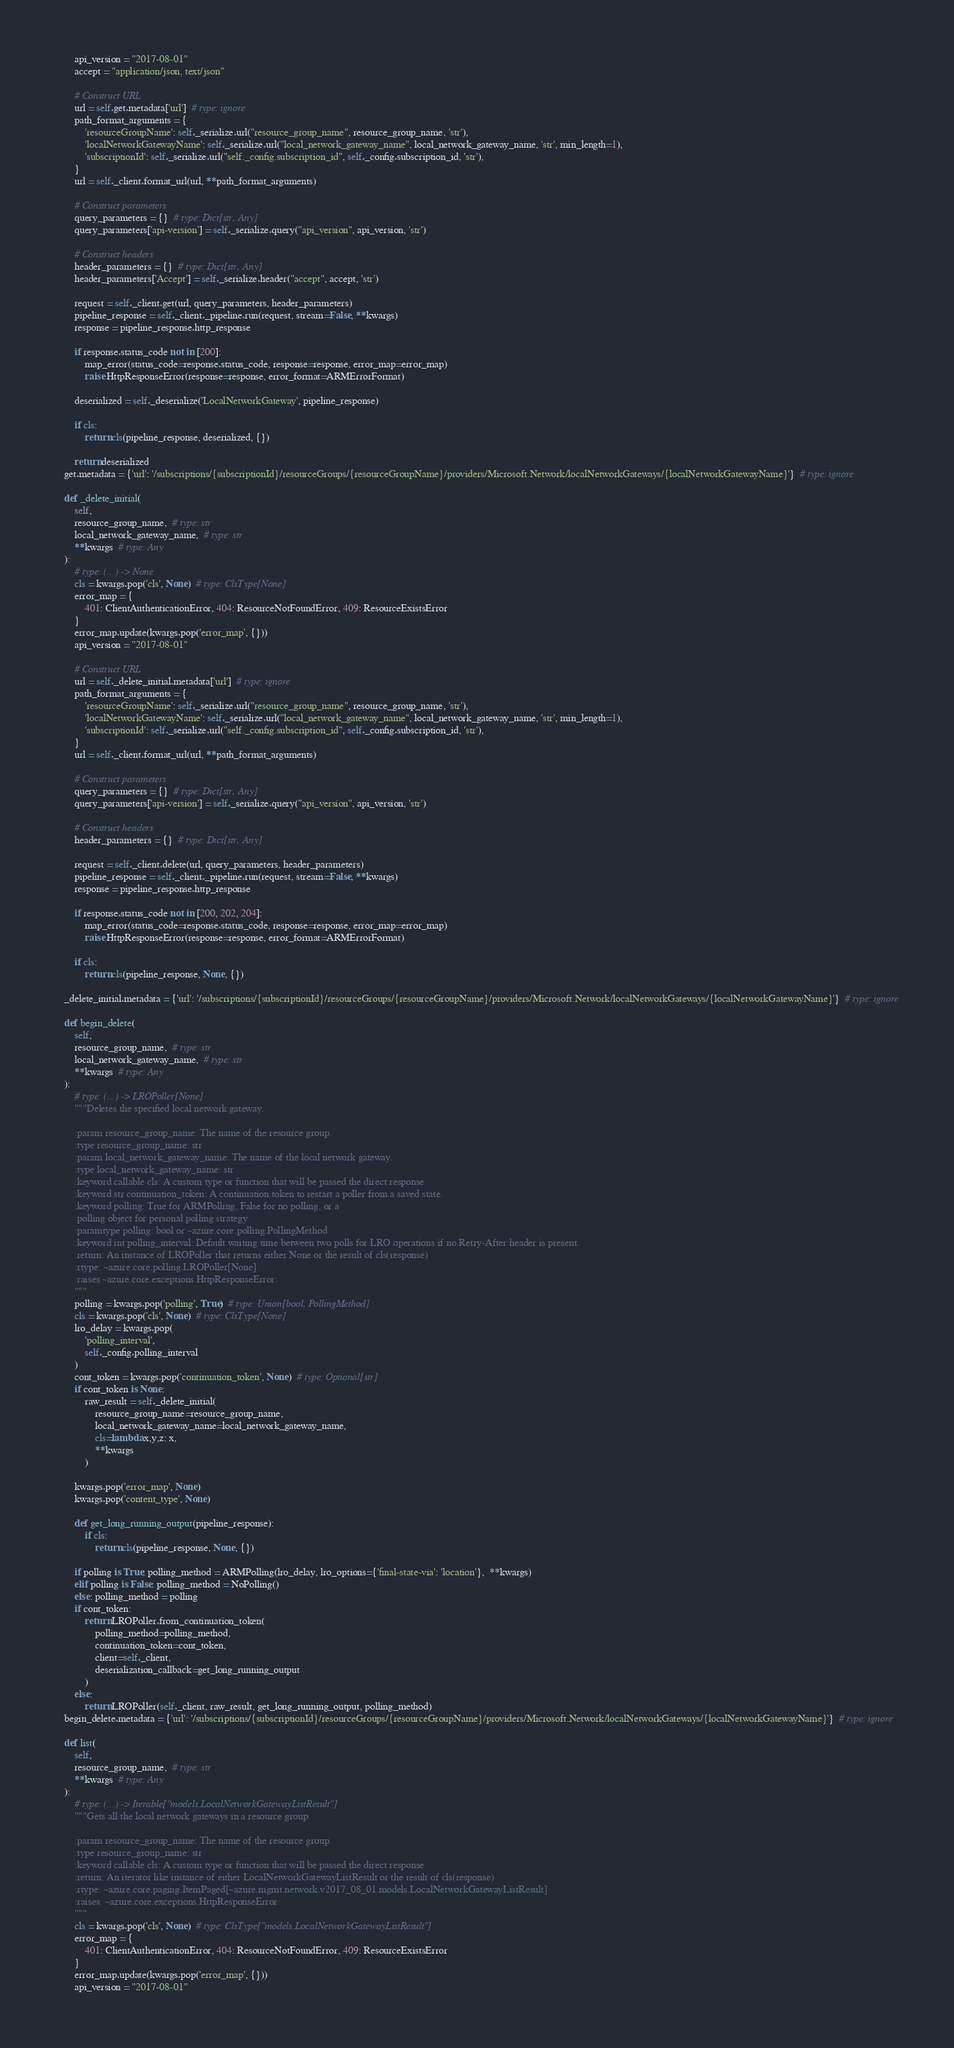<code> <loc_0><loc_0><loc_500><loc_500><_Python_>        api_version = "2017-08-01"
        accept = "application/json, text/json"

        # Construct URL
        url = self.get.metadata['url']  # type: ignore
        path_format_arguments = {
            'resourceGroupName': self._serialize.url("resource_group_name", resource_group_name, 'str'),
            'localNetworkGatewayName': self._serialize.url("local_network_gateway_name", local_network_gateway_name, 'str', min_length=1),
            'subscriptionId': self._serialize.url("self._config.subscription_id", self._config.subscription_id, 'str'),
        }
        url = self._client.format_url(url, **path_format_arguments)

        # Construct parameters
        query_parameters = {}  # type: Dict[str, Any]
        query_parameters['api-version'] = self._serialize.query("api_version", api_version, 'str')

        # Construct headers
        header_parameters = {}  # type: Dict[str, Any]
        header_parameters['Accept'] = self._serialize.header("accept", accept, 'str')

        request = self._client.get(url, query_parameters, header_parameters)
        pipeline_response = self._client._pipeline.run(request, stream=False, **kwargs)
        response = pipeline_response.http_response

        if response.status_code not in [200]:
            map_error(status_code=response.status_code, response=response, error_map=error_map)
            raise HttpResponseError(response=response, error_format=ARMErrorFormat)

        deserialized = self._deserialize('LocalNetworkGateway', pipeline_response)

        if cls:
            return cls(pipeline_response, deserialized, {})

        return deserialized
    get.metadata = {'url': '/subscriptions/{subscriptionId}/resourceGroups/{resourceGroupName}/providers/Microsoft.Network/localNetworkGateways/{localNetworkGatewayName}'}  # type: ignore

    def _delete_initial(
        self,
        resource_group_name,  # type: str
        local_network_gateway_name,  # type: str
        **kwargs  # type: Any
    ):
        # type: (...) -> None
        cls = kwargs.pop('cls', None)  # type: ClsType[None]
        error_map = {
            401: ClientAuthenticationError, 404: ResourceNotFoundError, 409: ResourceExistsError
        }
        error_map.update(kwargs.pop('error_map', {}))
        api_version = "2017-08-01"

        # Construct URL
        url = self._delete_initial.metadata['url']  # type: ignore
        path_format_arguments = {
            'resourceGroupName': self._serialize.url("resource_group_name", resource_group_name, 'str'),
            'localNetworkGatewayName': self._serialize.url("local_network_gateway_name", local_network_gateway_name, 'str', min_length=1),
            'subscriptionId': self._serialize.url("self._config.subscription_id", self._config.subscription_id, 'str'),
        }
        url = self._client.format_url(url, **path_format_arguments)

        # Construct parameters
        query_parameters = {}  # type: Dict[str, Any]
        query_parameters['api-version'] = self._serialize.query("api_version", api_version, 'str')

        # Construct headers
        header_parameters = {}  # type: Dict[str, Any]

        request = self._client.delete(url, query_parameters, header_parameters)
        pipeline_response = self._client._pipeline.run(request, stream=False, **kwargs)
        response = pipeline_response.http_response

        if response.status_code not in [200, 202, 204]:
            map_error(status_code=response.status_code, response=response, error_map=error_map)
            raise HttpResponseError(response=response, error_format=ARMErrorFormat)

        if cls:
            return cls(pipeline_response, None, {})

    _delete_initial.metadata = {'url': '/subscriptions/{subscriptionId}/resourceGroups/{resourceGroupName}/providers/Microsoft.Network/localNetworkGateways/{localNetworkGatewayName}'}  # type: ignore

    def begin_delete(
        self,
        resource_group_name,  # type: str
        local_network_gateway_name,  # type: str
        **kwargs  # type: Any
    ):
        # type: (...) -> LROPoller[None]
        """Deletes the specified local network gateway.

        :param resource_group_name: The name of the resource group.
        :type resource_group_name: str
        :param local_network_gateway_name: The name of the local network gateway.
        :type local_network_gateway_name: str
        :keyword callable cls: A custom type or function that will be passed the direct response
        :keyword str continuation_token: A continuation token to restart a poller from a saved state.
        :keyword polling: True for ARMPolling, False for no polling, or a
         polling object for personal polling strategy
        :paramtype polling: bool or ~azure.core.polling.PollingMethod
        :keyword int polling_interval: Default waiting time between two polls for LRO operations if no Retry-After header is present.
        :return: An instance of LROPoller that returns either None or the result of cls(response)
        :rtype: ~azure.core.polling.LROPoller[None]
        :raises ~azure.core.exceptions.HttpResponseError:
        """
        polling = kwargs.pop('polling', True)  # type: Union[bool, PollingMethod]
        cls = kwargs.pop('cls', None)  # type: ClsType[None]
        lro_delay = kwargs.pop(
            'polling_interval',
            self._config.polling_interval
        )
        cont_token = kwargs.pop('continuation_token', None)  # type: Optional[str]
        if cont_token is None:
            raw_result = self._delete_initial(
                resource_group_name=resource_group_name,
                local_network_gateway_name=local_network_gateway_name,
                cls=lambda x,y,z: x,
                **kwargs
            )

        kwargs.pop('error_map', None)
        kwargs.pop('content_type', None)

        def get_long_running_output(pipeline_response):
            if cls:
                return cls(pipeline_response, None, {})

        if polling is True: polling_method = ARMPolling(lro_delay, lro_options={'final-state-via': 'location'},  **kwargs)
        elif polling is False: polling_method = NoPolling()
        else: polling_method = polling
        if cont_token:
            return LROPoller.from_continuation_token(
                polling_method=polling_method,
                continuation_token=cont_token,
                client=self._client,
                deserialization_callback=get_long_running_output
            )
        else:
            return LROPoller(self._client, raw_result, get_long_running_output, polling_method)
    begin_delete.metadata = {'url': '/subscriptions/{subscriptionId}/resourceGroups/{resourceGroupName}/providers/Microsoft.Network/localNetworkGateways/{localNetworkGatewayName}'}  # type: ignore

    def list(
        self,
        resource_group_name,  # type: str
        **kwargs  # type: Any
    ):
        # type: (...) -> Iterable["models.LocalNetworkGatewayListResult"]
        """Gets all the local network gateways in a resource group.

        :param resource_group_name: The name of the resource group.
        :type resource_group_name: str
        :keyword callable cls: A custom type or function that will be passed the direct response
        :return: An iterator like instance of either LocalNetworkGatewayListResult or the result of cls(response)
        :rtype: ~azure.core.paging.ItemPaged[~azure.mgmt.network.v2017_08_01.models.LocalNetworkGatewayListResult]
        :raises: ~azure.core.exceptions.HttpResponseError
        """
        cls = kwargs.pop('cls', None)  # type: ClsType["models.LocalNetworkGatewayListResult"]
        error_map = {
            401: ClientAuthenticationError, 404: ResourceNotFoundError, 409: ResourceExistsError
        }
        error_map.update(kwargs.pop('error_map', {}))
        api_version = "2017-08-01"</code> 